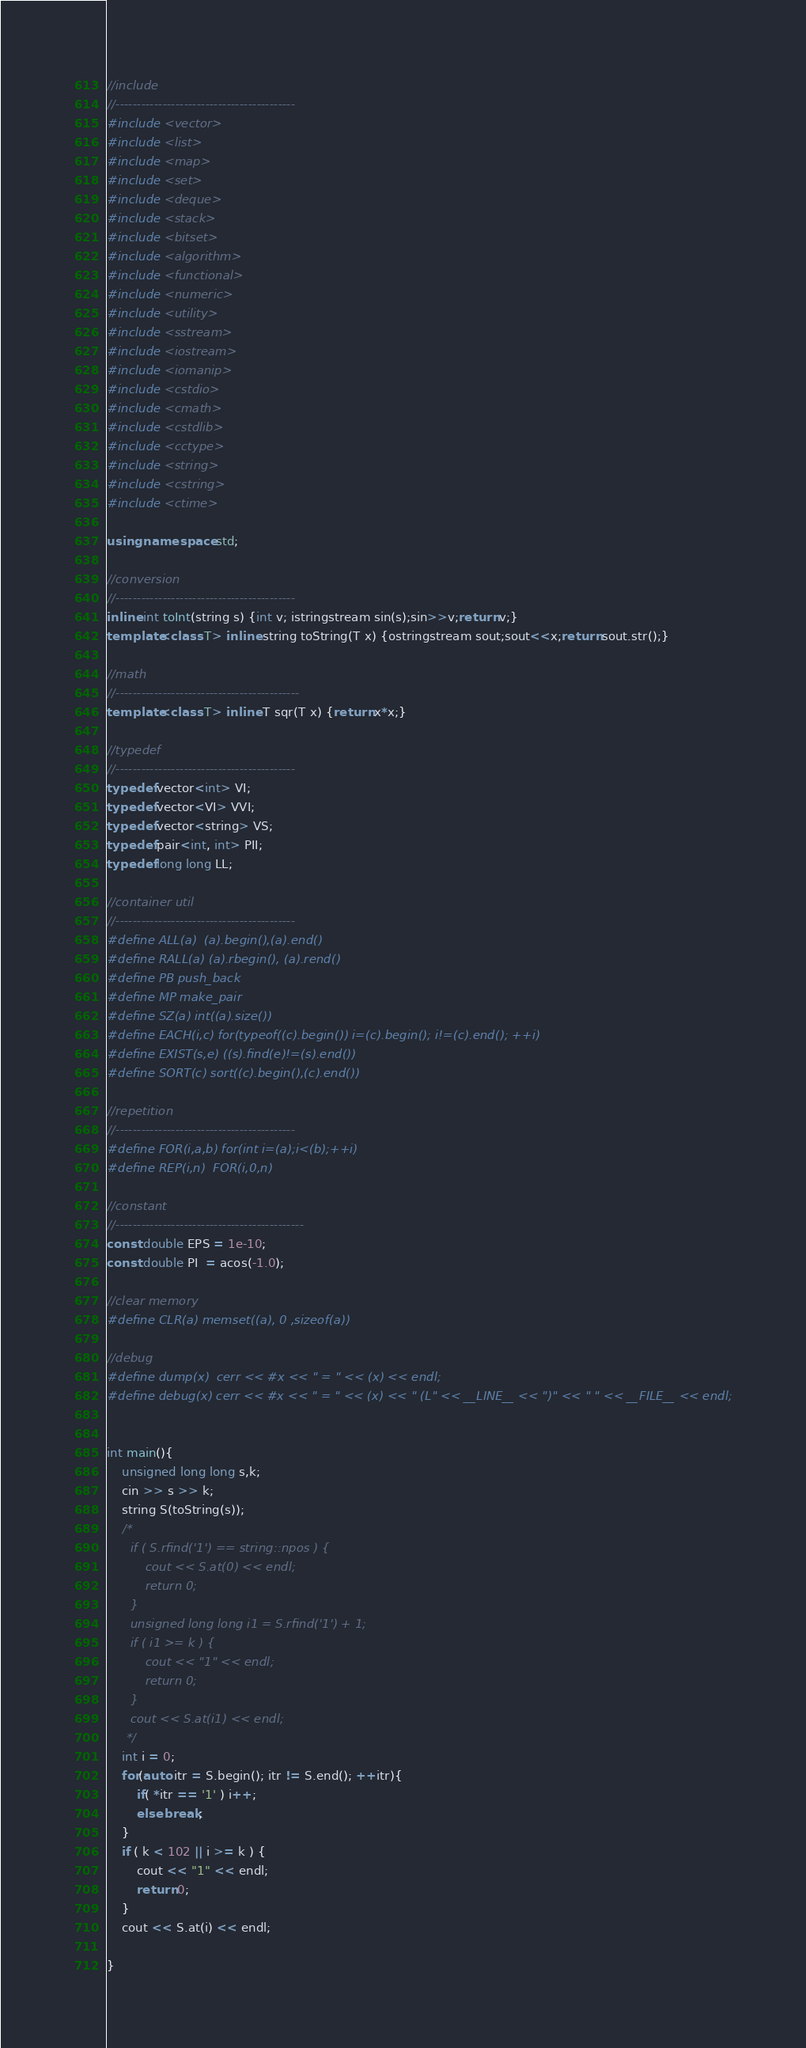Convert code to text. <code><loc_0><loc_0><loc_500><loc_500><_C++_>//include
//------------------------------------------
#include <vector>
#include <list>
#include <map>
#include <set>
#include <deque>
#include <stack>
#include <bitset>
#include <algorithm>
#include <functional>
#include <numeric>
#include <utility>
#include <sstream>
#include <iostream>
#include <iomanip>
#include <cstdio>
#include <cmath>
#include <cstdlib>
#include <cctype>
#include <string>
#include <cstring>
#include <ctime>

using namespace std;

//conversion
//------------------------------------------
inline int toInt(string s) {int v; istringstream sin(s);sin>>v;return v;}
template<class T> inline string toString(T x) {ostringstream sout;sout<<x;return sout.str();}

//math
//-------------------------------------------
template<class T> inline T sqr(T x) {return x*x;}

//typedef
//------------------------------------------
typedef vector<int> VI;
typedef vector<VI> VVI;
typedef vector<string> VS;
typedef pair<int, int> PII;
typedef long long LL;

//container util
//------------------------------------------
#define ALL(a)  (a).begin(),(a).end()
#define RALL(a) (a).rbegin(), (a).rend()
#define PB push_back
#define MP make_pair
#define SZ(a) int((a).size())
#define EACH(i,c) for(typeof((c).begin()) i=(c).begin(); i!=(c).end(); ++i)
#define EXIST(s,e) ((s).find(e)!=(s).end())
#define SORT(c) sort((c).begin(),(c).end())

//repetition
//------------------------------------------
#define FOR(i,a,b) for(int i=(a);i<(b);++i)
#define REP(i,n)  FOR(i,0,n)

//constant
//--------------------------------------------
const double EPS = 1e-10;
const double PI  = acos(-1.0);

//clear memory
#define CLR(a) memset((a), 0 ,sizeof(a))

//debug
#define dump(x)  cerr << #x << " = " << (x) << endl;
#define debug(x) cerr << #x << " = " << (x) << " (L" << __LINE__ << ")" << " " << __FILE__ << endl;


int main(){
    unsigned long long s,k;
    cin >> s >> k;
    string S(toString(s));
    /* 
      if ( S.rfind('1') == string::npos ) {
          cout << S.at(0) << endl;
          return 0;
      }  
      unsigned long long i1 = S.rfind('1') + 1;
      if ( i1 >= k ) {
          cout << "1" << endl;
          return 0;
      }
      cout << S.at(i1) << endl;
     */
    int i = 0;
    for(auto itr = S.begin(); itr != S.end(); ++itr){
        if( *itr == '1' ) i++;
        else break;
    }
    if ( k < 102 || i >= k ) {
        cout << "1" << endl;
        return 0;
    }
    cout << S.at(i) << endl;
        
}</code> 